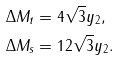Convert formula to latex. <formula><loc_0><loc_0><loc_500><loc_500>\Delta M _ { t } & = 4 \sqrt { 3 } y _ { 2 } , \\ \Delta M _ { s } & = 1 2 \sqrt { 3 } y _ { 2 } .</formula> 